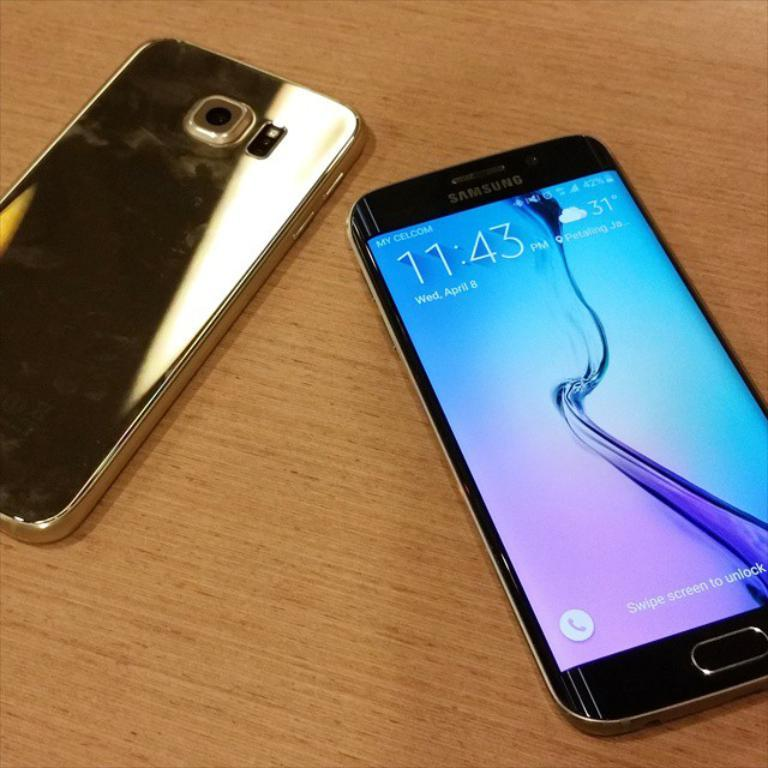<image>
Offer a succinct explanation of the picture presented. A Samsung phone displays the time of day as 11:43 PM. 